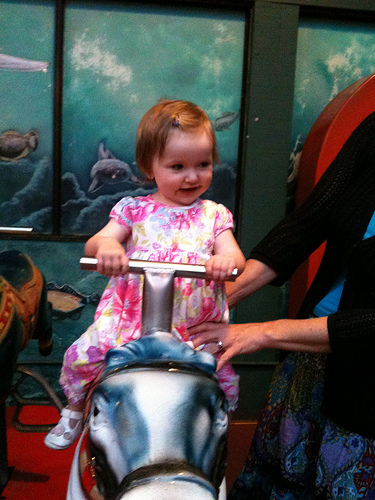<image>
Can you confirm if the baby is on the toy horse? Yes. Looking at the image, I can see the baby is positioned on top of the toy horse, with the toy horse providing support. Is the baby behind the bar? Yes. From this viewpoint, the baby is positioned behind the bar, with the bar partially or fully occluding the baby. 